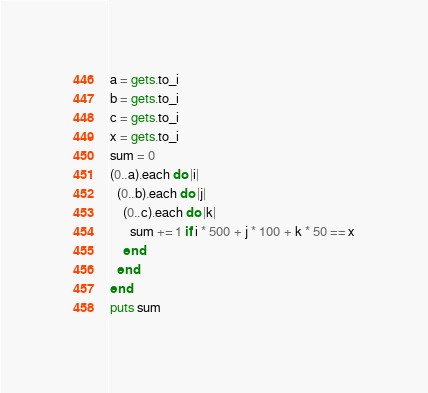<code> <loc_0><loc_0><loc_500><loc_500><_Ruby_>a = gets.to_i
b = gets.to_i
c = gets.to_i
x = gets.to_i
sum = 0
(0..a).each do |i|
  (0..b).each do |j|
    (0..c).each do |k|
      sum += 1 if i * 500 + j * 100 + k * 50 == x
    end
  end
end
puts sum</code> 